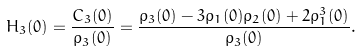<formula> <loc_0><loc_0><loc_500><loc_500>H _ { 3 } ( 0 ) = \frac { C _ { 3 } ( 0 ) } { \rho _ { 3 } ( 0 ) } = \frac { \rho _ { 3 } ( 0 ) - 3 \rho _ { 1 } ( 0 ) \rho _ { 2 } ( 0 ) + 2 \rho _ { 1 } ^ { 3 } ( 0 ) } { \rho _ { 3 } ( 0 ) } .</formula> 